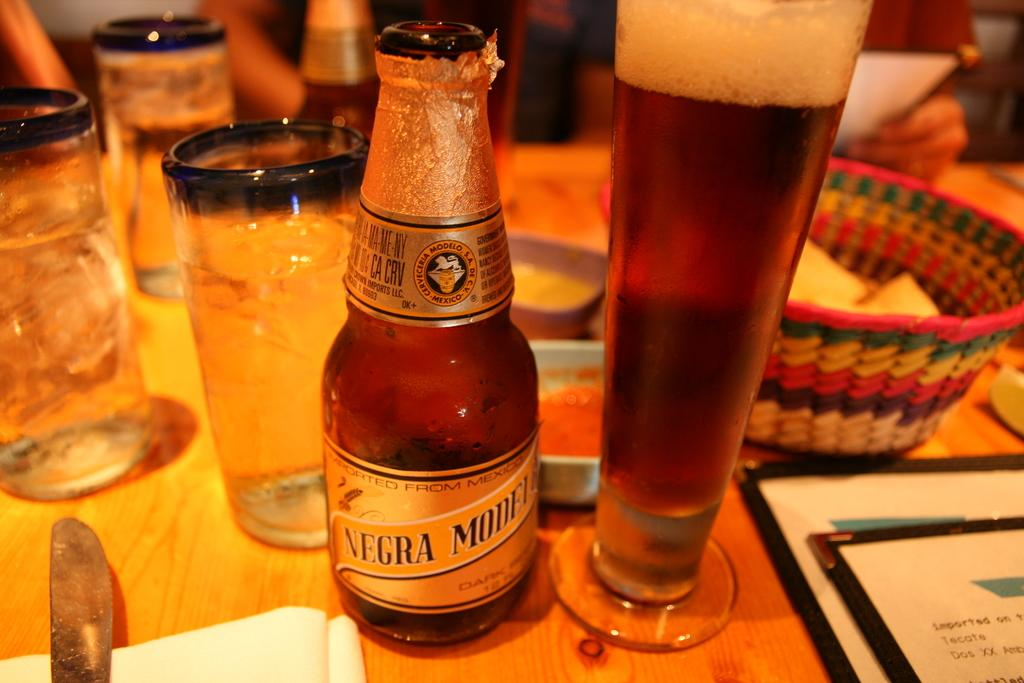<image>
Give a short and clear explanation of the subsequent image. A glass of beer and a bottle of Negra Modelo on a table. 